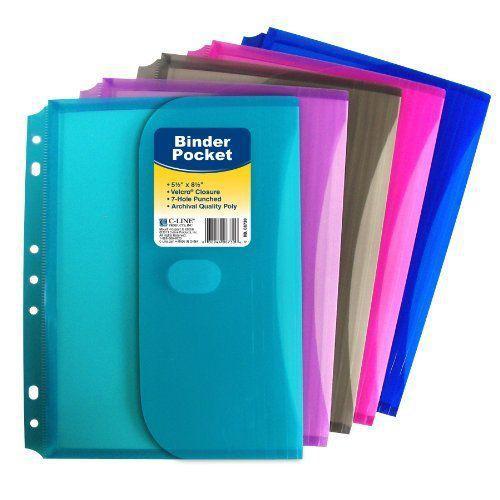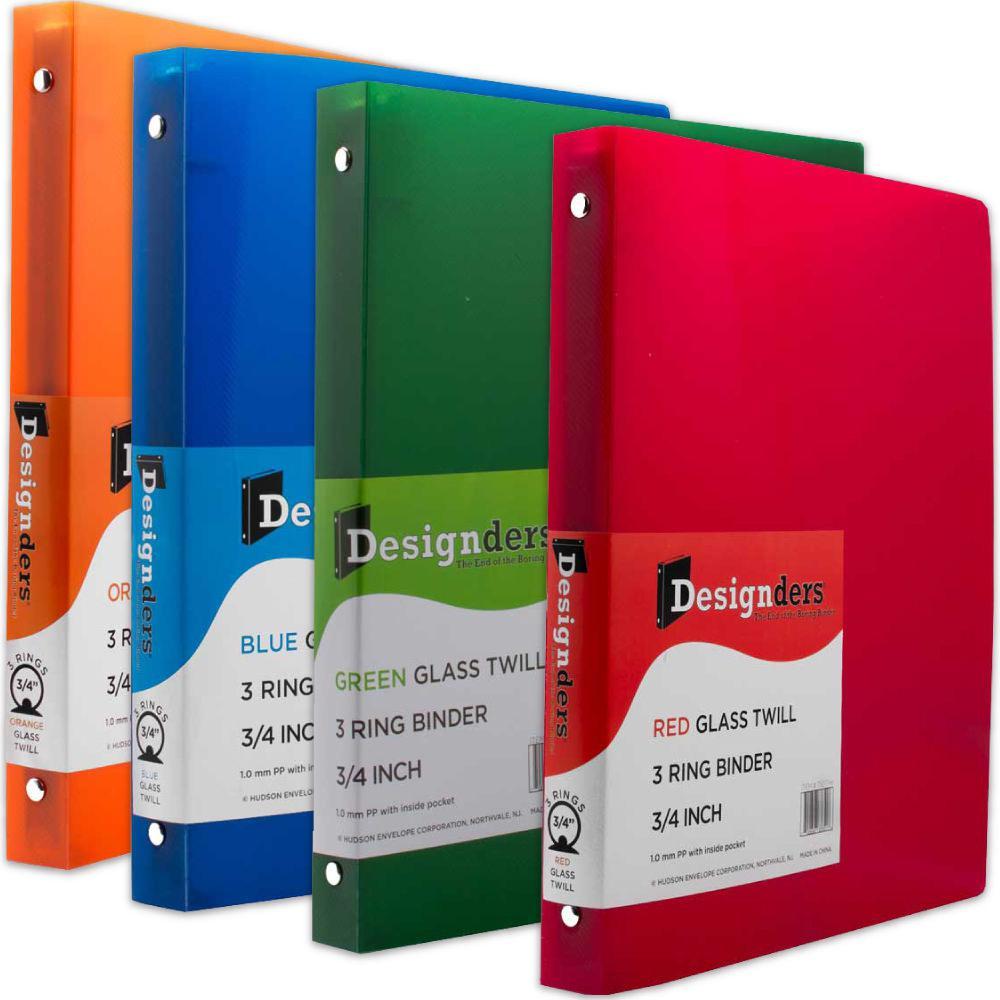The first image is the image on the left, the second image is the image on the right. Given the left and right images, does the statement "there are no more than four binders in the image on the right" hold true? Answer yes or no. Yes. 